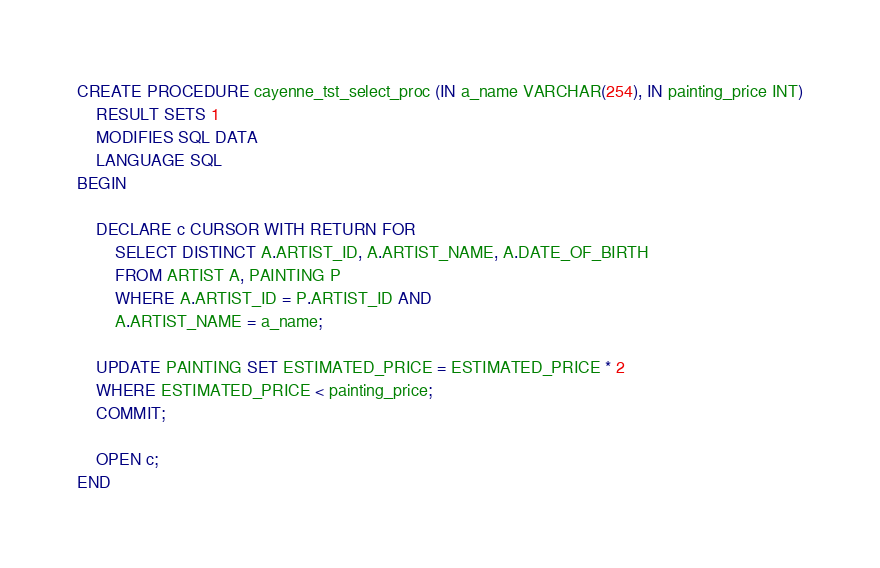Convert code to text. <code><loc_0><loc_0><loc_500><loc_500><_SQL_>CREATE PROCEDURE cayenne_tst_select_proc (IN a_name VARCHAR(254), IN painting_price INT)
	RESULT SETS 1
	MODIFIES SQL DATA
	LANGUAGE SQL
BEGIN

	DECLARE c CURSOR WITH RETURN FOR
		SELECT DISTINCT A.ARTIST_ID, A.ARTIST_NAME, A.DATE_OF_BIRTH
		FROM ARTIST A, PAINTING P 
		WHERE A.ARTIST_ID = P.ARTIST_ID AND
		A.ARTIST_NAME = a_name;
	
	UPDATE PAINTING SET ESTIMATED_PRICE = ESTIMATED_PRICE * 2
	WHERE ESTIMATED_PRICE < painting_price;
	COMMIT; 
	
	OPEN c;
END</code> 